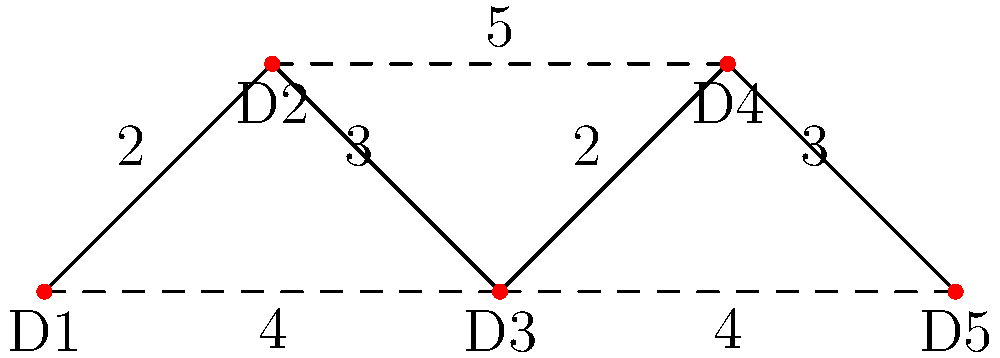Given the graph representing a document linking system where each node is a document and edge weights represent the time (in minutes) to establish links between documents, what is the minimum time required to link all documents while ensuring that every document is connected to at least one other document? To solve this problem, we need to find the Minimum Spanning Tree (MST) of the given graph. The MST will give us the minimum total weight (time) to connect all nodes (documents) while ensuring every node is connected.

We can use Kruskal's algorithm to find the MST:

1. Sort all edges by weight in ascending order:
   (D1-D2, 2), (D3-D4, 2), (D1-D3, 3), (D4-D5, 3), (D1-D3, 4), (D3-D5, 4), (D2-D4, 5)

2. Start with an empty set of edges and add edges one by one:
   - Add (D1-D2, 2)
   - Add (D3-D4, 2)
   - Add (D1-D3, 3) or (D4-D5, 3) (either works, let's choose D4-D5)
   - Add (D1-D3, 3)

3. We now have 4 edges connecting all 5 nodes, forming the MST.

4. Sum the weights of the selected edges:
   2 + 2 + 3 + 3 = 10

Therefore, the minimum time required to link all documents while ensuring every document is connected to at least one other document is 10 minutes.
Answer: 10 minutes 